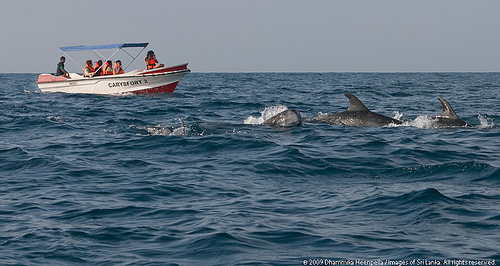<image>
Is there a boat in front of the fish? Yes. The boat is positioned in front of the fish, appearing closer to the camera viewpoint. 